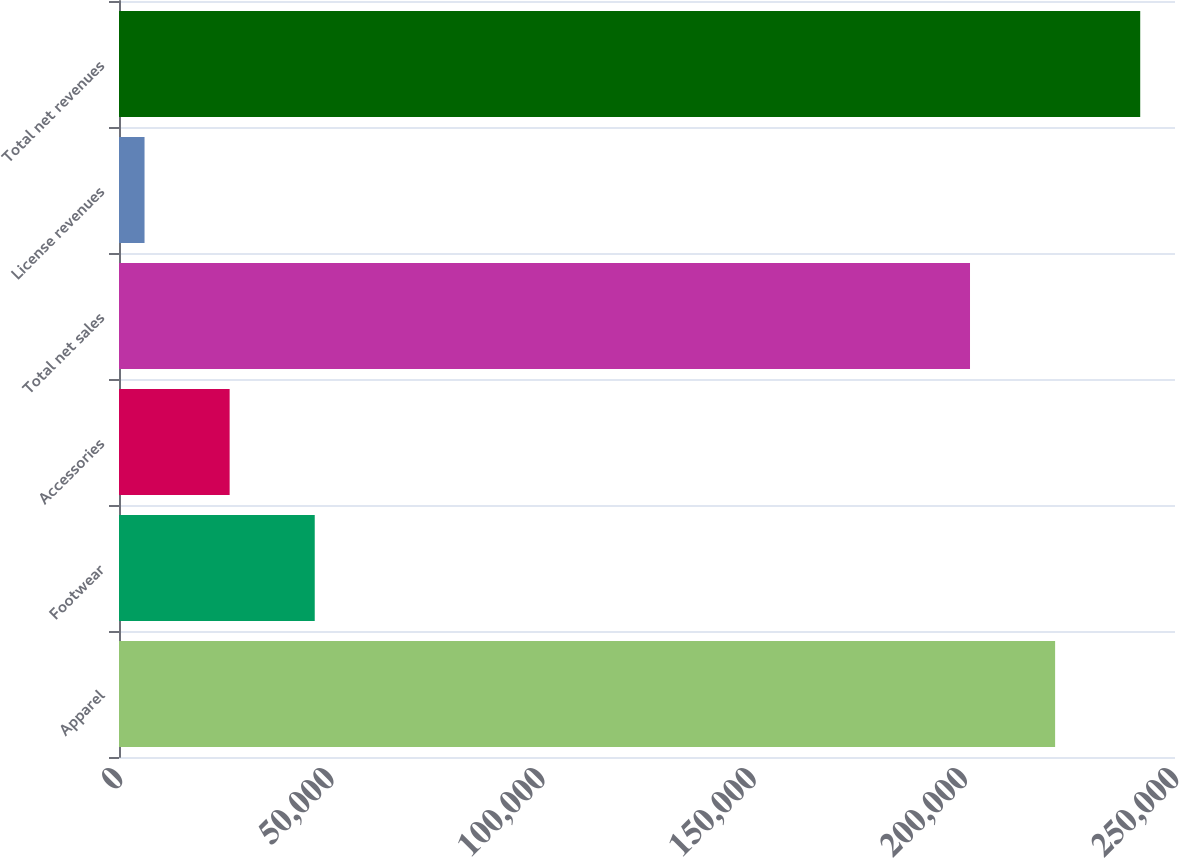Convert chart to OTSL. <chart><loc_0><loc_0><loc_500><loc_500><bar_chart><fcel>Apparel<fcel>Footwear<fcel>Accessories<fcel>Total net sales<fcel>License revenues<fcel>Total net revenues<nl><fcel>221617<fcel>46340<fcel>26193<fcel>201470<fcel>6046<fcel>241764<nl></chart> 